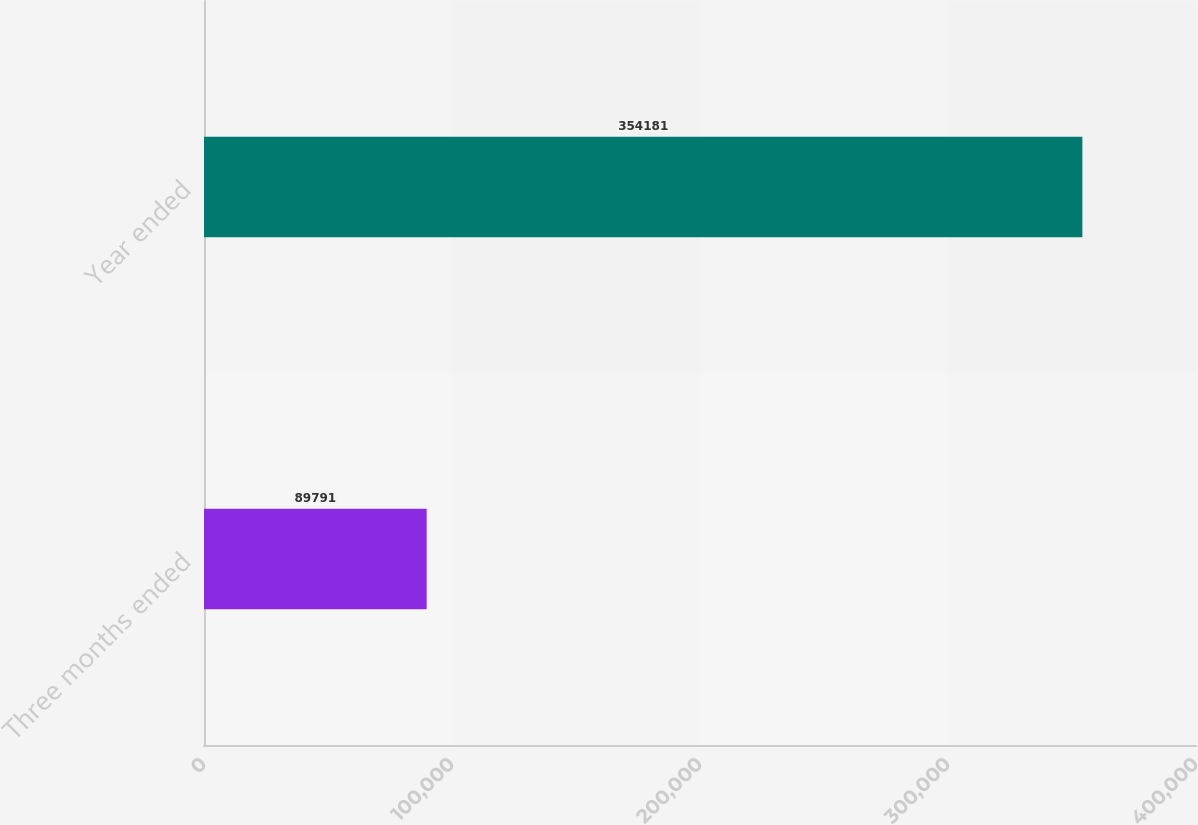Convert chart. <chart><loc_0><loc_0><loc_500><loc_500><bar_chart><fcel>Three months ended<fcel>Year ended<nl><fcel>89791<fcel>354181<nl></chart> 